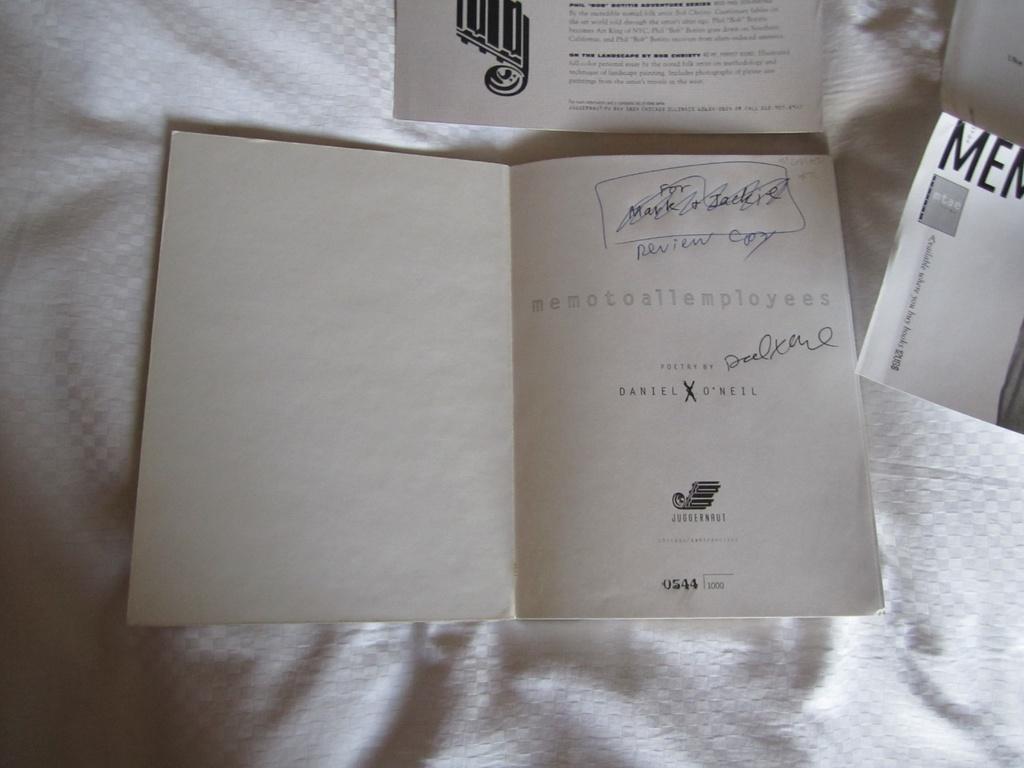What is written in ink on the page?
Give a very brief answer. Review copy. 